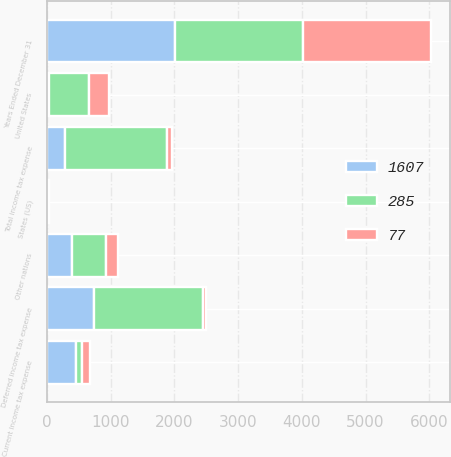<chart> <loc_0><loc_0><loc_500><loc_500><stacked_bar_chart><ecel><fcel>Years Ended December 31<fcel>United States<fcel>Other nations<fcel>States (US)<fcel>Current income tax expense<fcel>Deferred income tax expense<fcel>Total income tax expense<nl><fcel>77<fcel>2009<fcel>314<fcel>181<fcel>6<fcel>127<fcel>50<fcel>77<nl><fcel>285<fcel>2008<fcel>618<fcel>532<fcel>5<fcel>91<fcel>1698<fcel>1607<nl><fcel>1607<fcel>2007<fcel>40<fcel>402<fcel>20<fcel>462<fcel>747<fcel>285<nl></chart> 